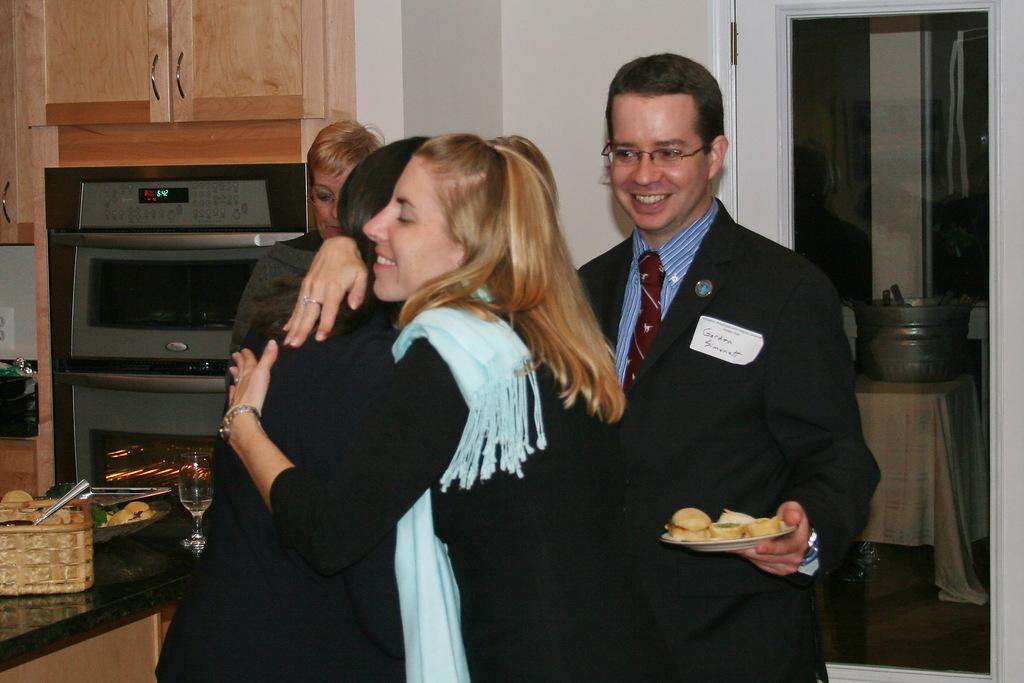Provide a one-sentence caption for the provided image. Gordon Simonatt watching two girls hug in a kitchen. 